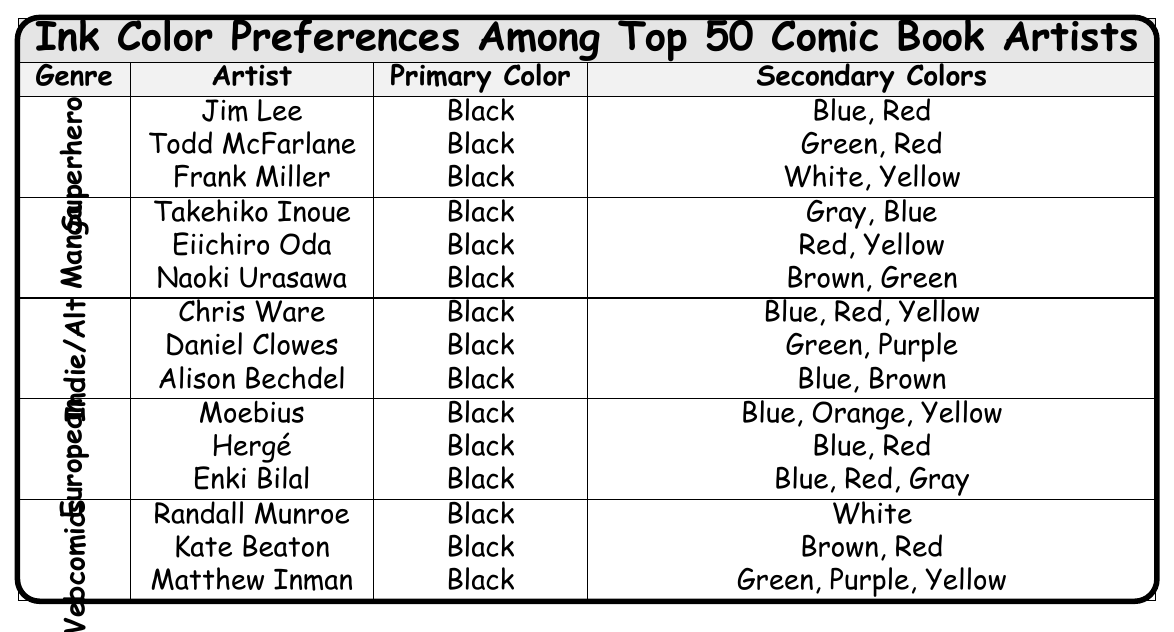What is the primary color preference for all artists listed in the table? All artists, regardless of genre, have a primary color of black as indicated in the table.
Answer: Black Which genre features the most artists in the table? The table lists three artists for each genre, making all genres equal in representation; hence, no genre has more artists than others.
Answer: Equal representation How many secondary colors do Chris Ware and Naoki Urasawa have combined? Chris Ware has three secondary colors (Blue, Red, Yellow) and Naoki Urasawa has two (Brown, Green). Adding them together gives 3 + 2 = 5 secondary colors.
Answer: 5 Do any artists in the European genre use orange as a secondary color? Looking at the European genre, Moebius is the only artist that has orange listed as a secondary color. Thus, the answer is yes.
Answer: Yes Which artist among the top 50 comic book artists uses the most diverse set of secondary colors? Chris Ware has the highest variety with three secondary colors (Blue, Red, Yellow), while others have up to three but no more. This indicates he uses the most diverse secondary colors.
Answer: Chris Ware In how many different genres do artists use green as a secondary color? The table shows that Todd McFarlane (Superhero), Daniel Clowes (Indie/Alternative), and Matthew Inman (Webcomics) use green, which means green appears in three different genres.
Answer: 3 Is there any artist in the Webcomics genre who has more than two secondary colors? Examining the artists listed under Webcomics, Matthew Inman is the only one with three secondary colors (Green, Purple, Yellow), which confirms the answer is yes.
Answer: Yes How many artists under the Indie/Alternative genre have blue as a secondary color? Chris Ware and Alison Bechdel both have blue listed as a secondary color, thus indicating there are two artists in the Indie/Alternative genre who include blue.
Answer: 2 